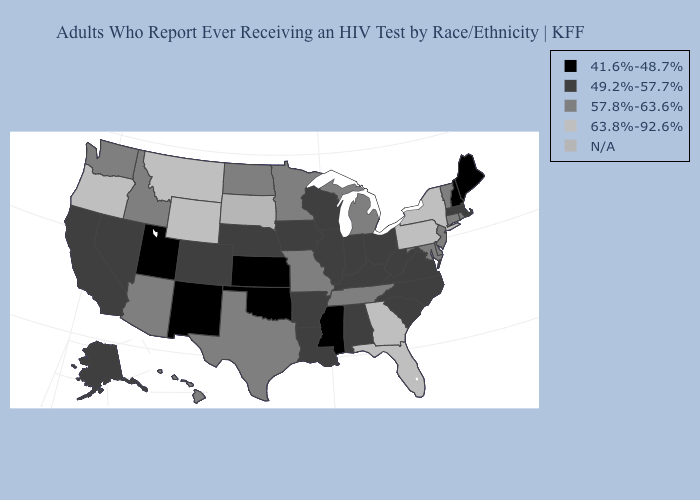What is the value of Pennsylvania?
Answer briefly. 63.8%-92.6%. Among the states that border South Dakota , does North Dakota have the lowest value?
Short answer required. No. Does Nebraska have the lowest value in the USA?
Short answer required. No. Among the states that border Missouri , which have the highest value?
Be succinct. Tennessee. Does the first symbol in the legend represent the smallest category?
Keep it brief. Yes. What is the value of Pennsylvania?
Quick response, please. 63.8%-92.6%. What is the lowest value in the USA?
Keep it brief. 41.6%-48.7%. What is the lowest value in the USA?
Short answer required. 41.6%-48.7%. Name the states that have a value in the range 57.8%-63.6%?
Answer briefly. Arizona, Connecticut, Delaware, Hawaii, Idaho, Maryland, Michigan, Minnesota, Missouri, New Jersey, North Dakota, Rhode Island, Tennessee, Texas, Vermont, Washington. Among the states that border Wisconsin , does Iowa have the lowest value?
Write a very short answer. Yes. Among the states that border New Hampshire , does Vermont have the highest value?
Answer briefly. Yes. Name the states that have a value in the range 49.2%-57.7%?
Concise answer only. Alabama, Alaska, Arkansas, California, Colorado, Illinois, Indiana, Iowa, Kentucky, Louisiana, Massachusetts, Nebraska, Nevada, North Carolina, Ohio, South Carolina, Virginia, West Virginia, Wisconsin. 